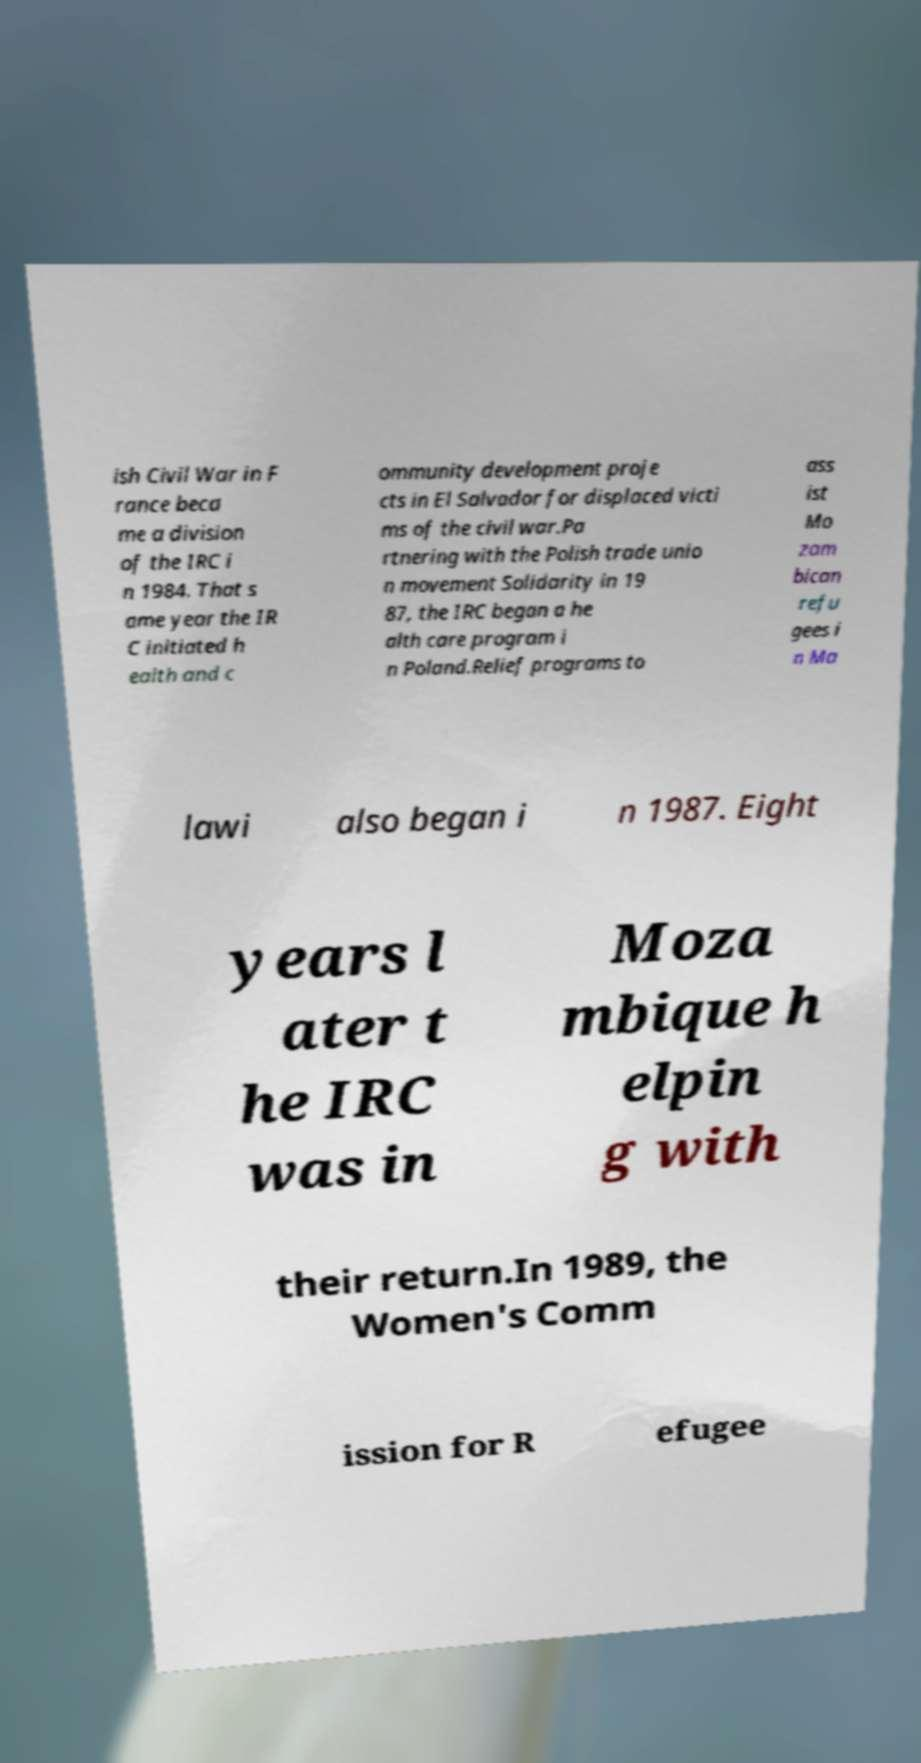For documentation purposes, I need the text within this image transcribed. Could you provide that? ish Civil War in F rance beca me a division of the IRC i n 1984. That s ame year the IR C initiated h ealth and c ommunity development proje cts in El Salvador for displaced victi ms of the civil war.Pa rtnering with the Polish trade unio n movement Solidarity in 19 87, the IRC began a he alth care program i n Poland.Relief programs to ass ist Mo zam bican refu gees i n Ma lawi also began i n 1987. Eight years l ater t he IRC was in Moza mbique h elpin g with their return.In 1989, the Women's Comm ission for R efugee 